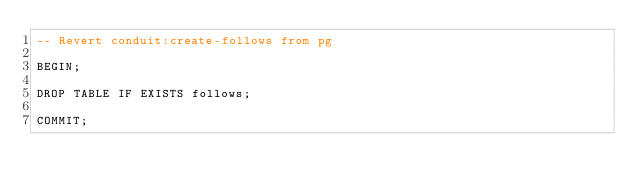Convert code to text. <code><loc_0><loc_0><loc_500><loc_500><_SQL_>-- Revert conduit:create-follows from pg

BEGIN;

DROP TABLE IF EXISTS follows;

COMMIT;
</code> 